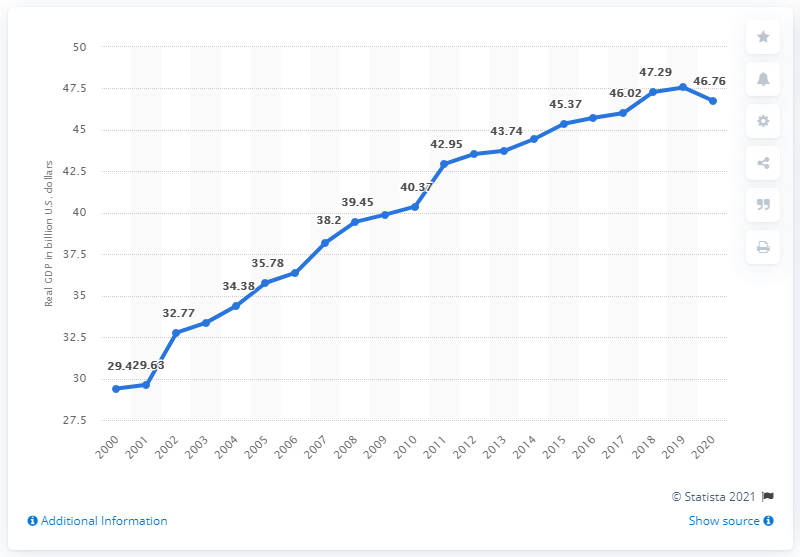Specify some key components in this picture. In 2020, the real GDP of South Dakota was 46.76. In 2018, South Dakota's real GDP was $47.56 billion. 